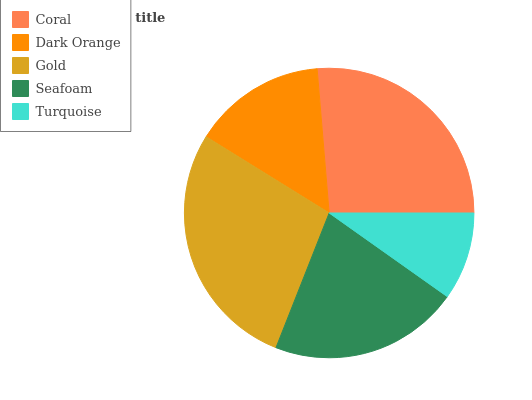Is Turquoise the minimum?
Answer yes or no. Yes. Is Gold the maximum?
Answer yes or no. Yes. Is Dark Orange the minimum?
Answer yes or no. No. Is Dark Orange the maximum?
Answer yes or no. No. Is Coral greater than Dark Orange?
Answer yes or no. Yes. Is Dark Orange less than Coral?
Answer yes or no. Yes. Is Dark Orange greater than Coral?
Answer yes or no. No. Is Coral less than Dark Orange?
Answer yes or no. No. Is Seafoam the high median?
Answer yes or no. Yes. Is Seafoam the low median?
Answer yes or no. Yes. Is Coral the high median?
Answer yes or no. No. Is Turquoise the low median?
Answer yes or no. No. 